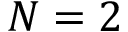<formula> <loc_0><loc_0><loc_500><loc_500>N = 2</formula> 